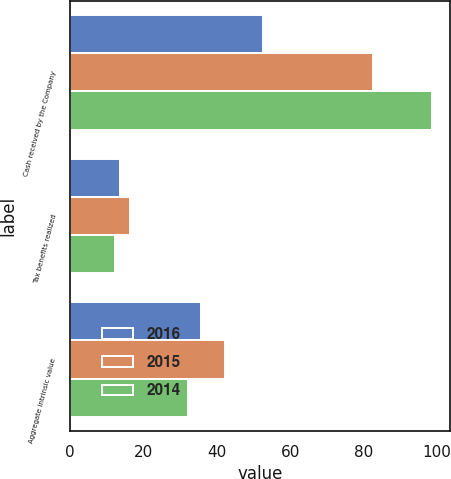Convert chart to OTSL. <chart><loc_0><loc_0><loc_500><loc_500><stacked_bar_chart><ecel><fcel>Cash received by the Company<fcel>Tax benefits realized<fcel>Aggregate intrinsic value<nl><fcel>2016<fcel>52.6<fcel>13.6<fcel>35.5<nl><fcel>2015<fcel>82.6<fcel>16.2<fcel>42.2<nl><fcel>2014<fcel>98.5<fcel>12.3<fcel>32.1<nl></chart> 